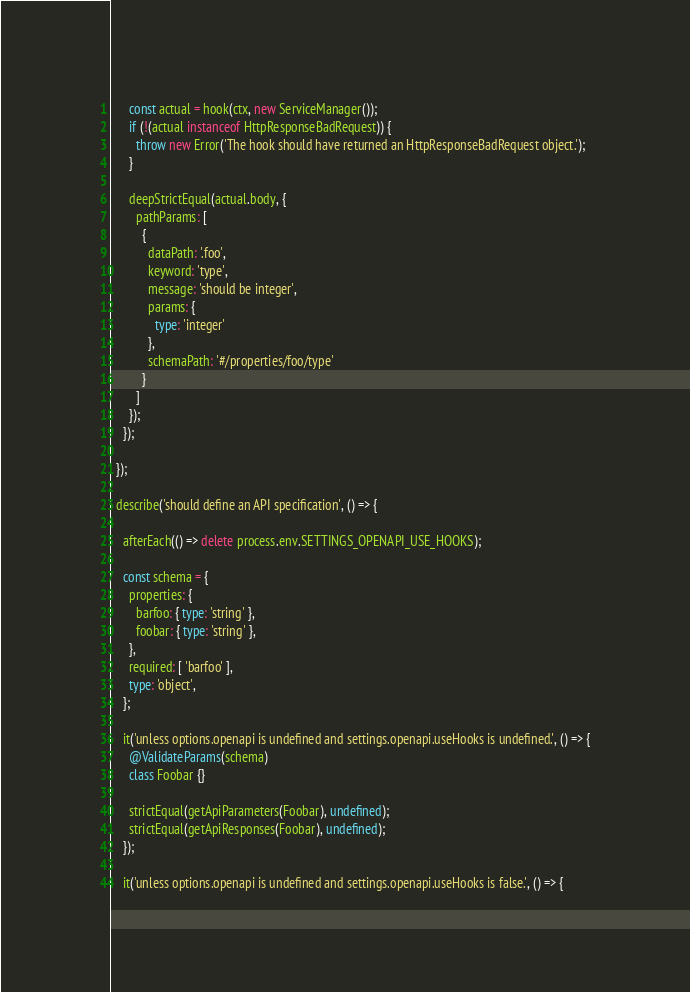Convert code to text. <code><loc_0><loc_0><loc_500><loc_500><_TypeScript_>
      const actual = hook(ctx, new ServiceManager());
      if (!(actual instanceof HttpResponseBadRequest)) {
        throw new Error('The hook should have returned an HttpResponseBadRequest object.');
      }

      deepStrictEqual(actual.body, {
        pathParams: [
          {
            dataPath: '.foo',
            keyword: 'type',
            message: 'should be integer',
            params: {
              type: 'integer'
            },
            schemaPath: '#/properties/foo/type'
          }
        ]
      });
    });

  });

  describe('should define an API specification', () => {

    afterEach(() => delete process.env.SETTINGS_OPENAPI_USE_HOOKS);

    const schema = {
      properties: {
        barfoo: { type: 'string' },
        foobar: { type: 'string' },
      },
      required: [ 'barfoo' ],
      type: 'object',
    };

    it('unless options.openapi is undefined and settings.openapi.useHooks is undefined.', () => {
      @ValidateParams(schema)
      class Foobar {}

      strictEqual(getApiParameters(Foobar), undefined);
      strictEqual(getApiResponses(Foobar), undefined);
    });

    it('unless options.openapi is undefined and settings.openapi.useHooks is false.', () => {</code> 